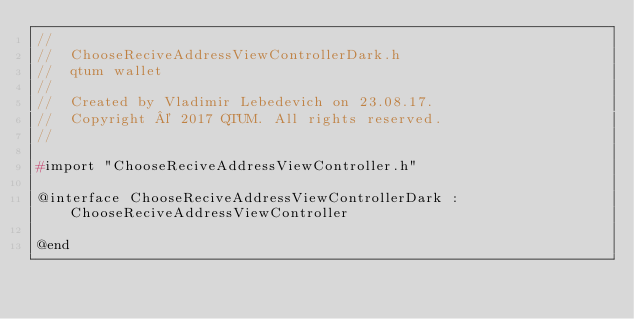<code> <loc_0><loc_0><loc_500><loc_500><_C_>//
//  ChooseReciveAddressViewControllerDark.h
//  qtum wallet
//
//  Created by Vladimir Lebedevich on 23.08.17.
//  Copyright © 2017 QTUM. All rights reserved.
//

#import "ChooseReciveAddressViewController.h"

@interface ChooseReciveAddressViewControllerDark : ChooseReciveAddressViewController

@end
</code> 